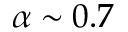Convert formula to latex. <formula><loc_0><loc_0><loc_500><loc_500>\alpha \sim 0 . 7</formula> 